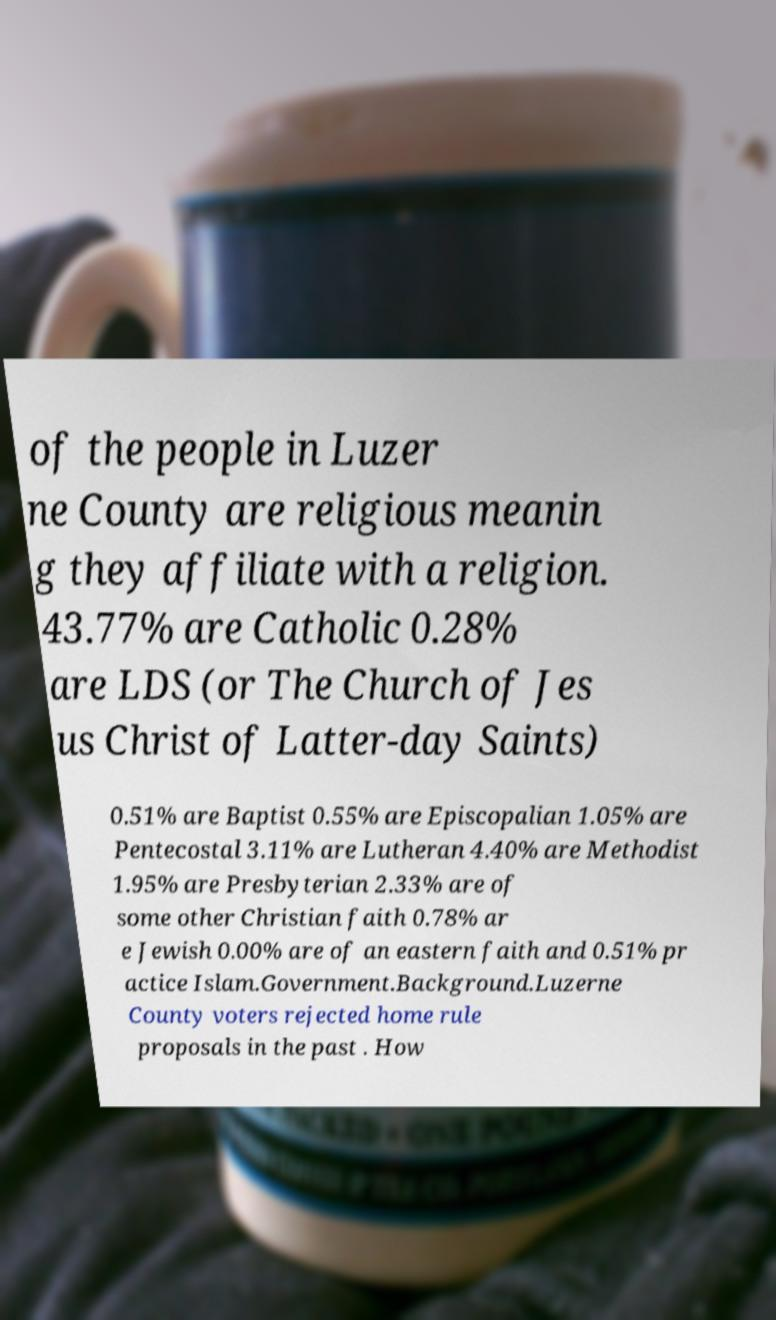Please identify and transcribe the text found in this image. of the people in Luzer ne County are religious meanin g they affiliate with a religion. 43.77% are Catholic 0.28% are LDS (or The Church of Jes us Christ of Latter-day Saints) 0.51% are Baptist 0.55% are Episcopalian 1.05% are Pentecostal 3.11% are Lutheran 4.40% are Methodist 1.95% are Presbyterian 2.33% are of some other Christian faith 0.78% ar e Jewish 0.00% are of an eastern faith and 0.51% pr actice Islam.Government.Background.Luzerne County voters rejected home rule proposals in the past . How 